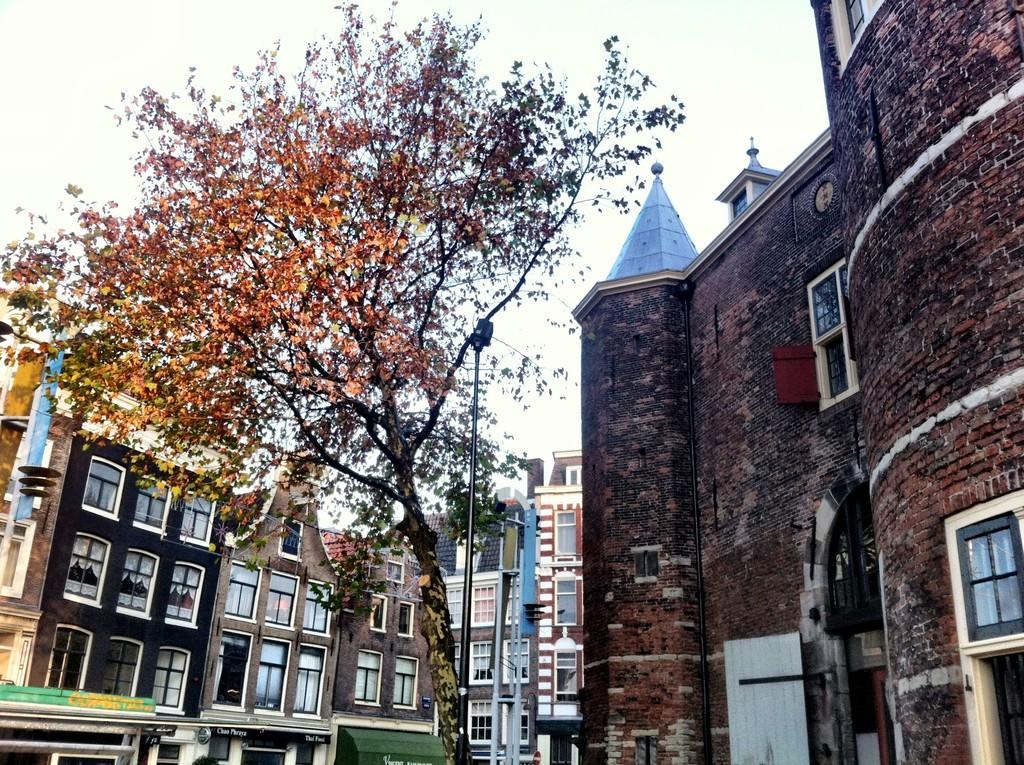What type of structures can be seen in the image? There are buildings in the image. What else is present in the image besides the buildings? There are poles and a tree visible in the image. What can be seen in the background of the image? The sky is visible in the image. How many grapes are hanging from the tree in the image? There are no grapes present in the image; it features a tree without any fruit. What type of tool is being used to fix the building in the image? There is no tool visible in the image, and no repair work is being done on the buildings. 